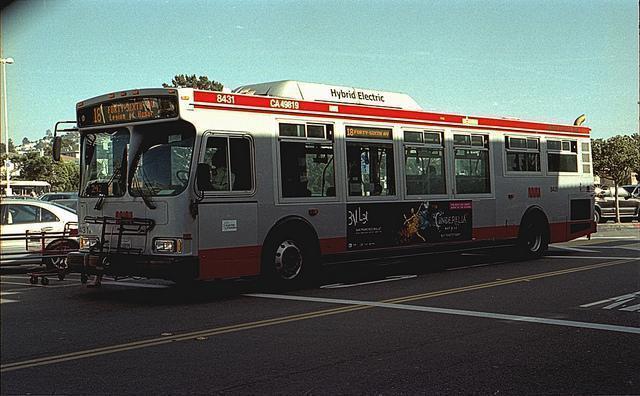How many wheels are visible on the large vehicle?
From the following four choices, select the correct answer to address the question.
Options: Two, three, six, four. Two. 